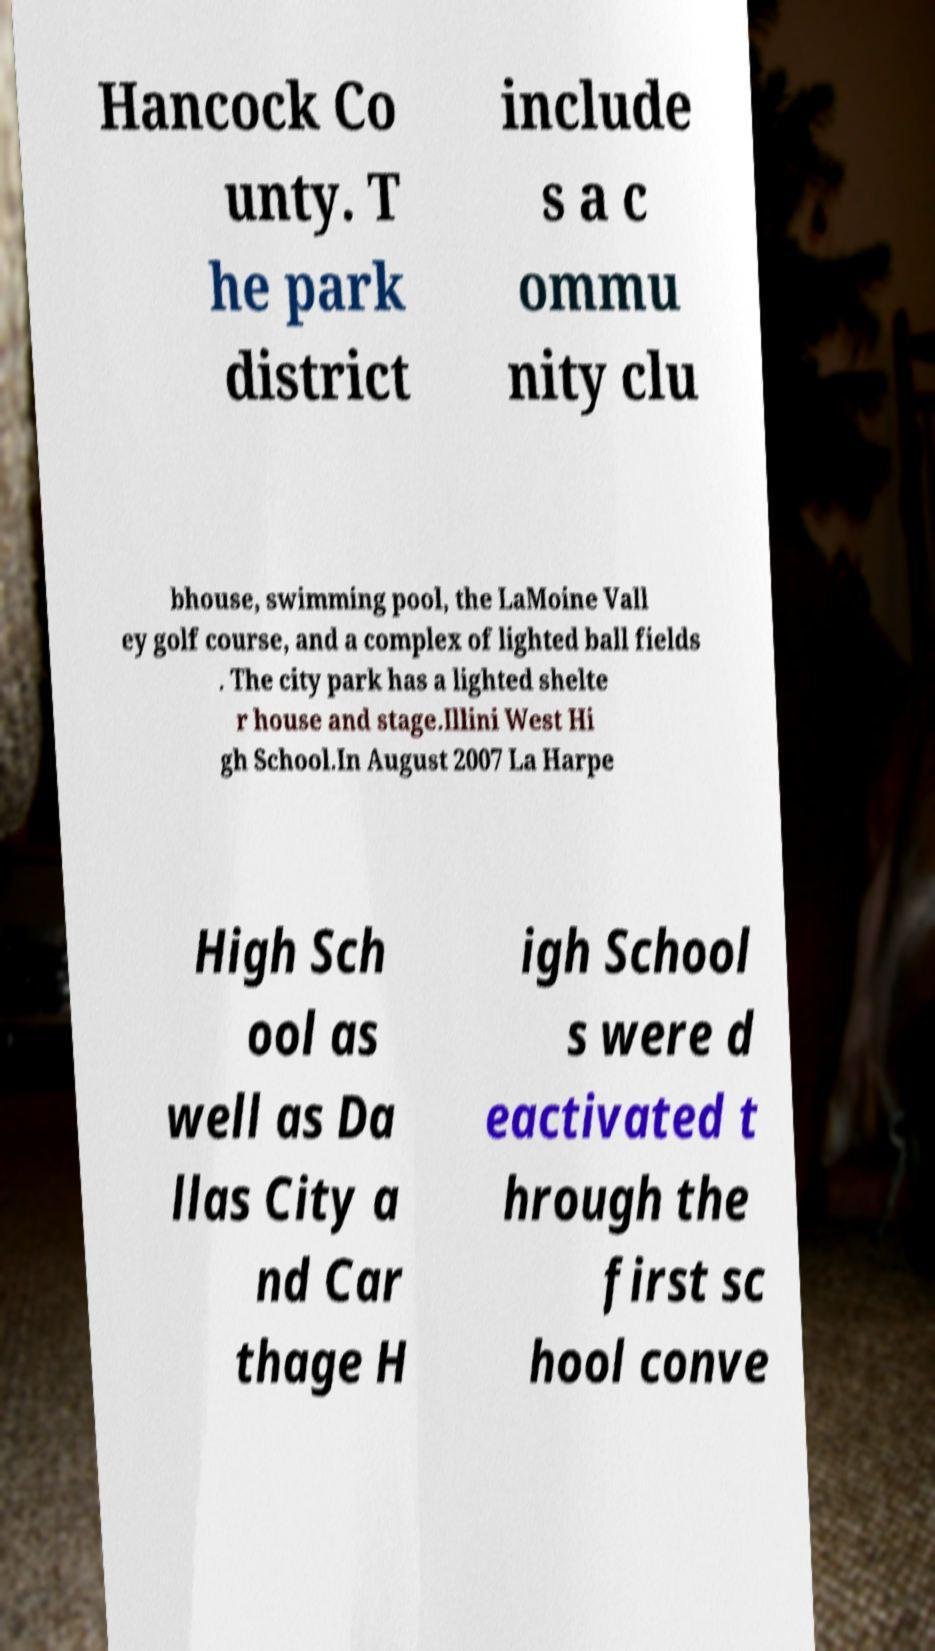Please read and relay the text visible in this image. What does it say? Hancock Co unty. T he park district include s a c ommu nity clu bhouse, swimming pool, the LaMoine Vall ey golf course, and a complex of lighted ball fields . The city park has a lighted shelte r house and stage.Illini West Hi gh School.In August 2007 La Harpe High Sch ool as well as Da llas City a nd Car thage H igh School s were d eactivated t hrough the first sc hool conve 